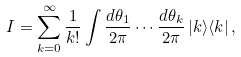Convert formula to latex. <formula><loc_0><loc_0><loc_500><loc_500>I = \sum _ { k = 0 } ^ { \infty } \frac { 1 } { k ! } \int \frac { d \theta _ { 1 } } { 2 \pi } \cdots \frac { d \theta _ { k } } { 2 \pi } \, | k \rangle \langle k | \, ,</formula> 